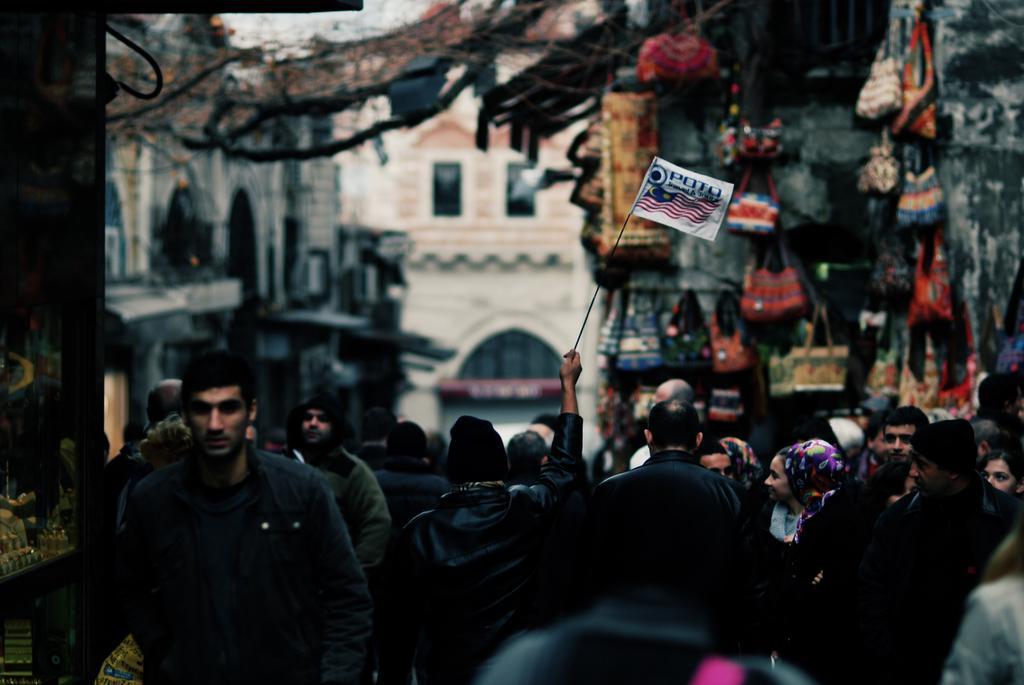Describe this image in one or two sentences. In this image I can see group of people. In front the person is wearing black color jacket and holding the flag. Background I can see few bags in multi color and I can also see few buildings. 